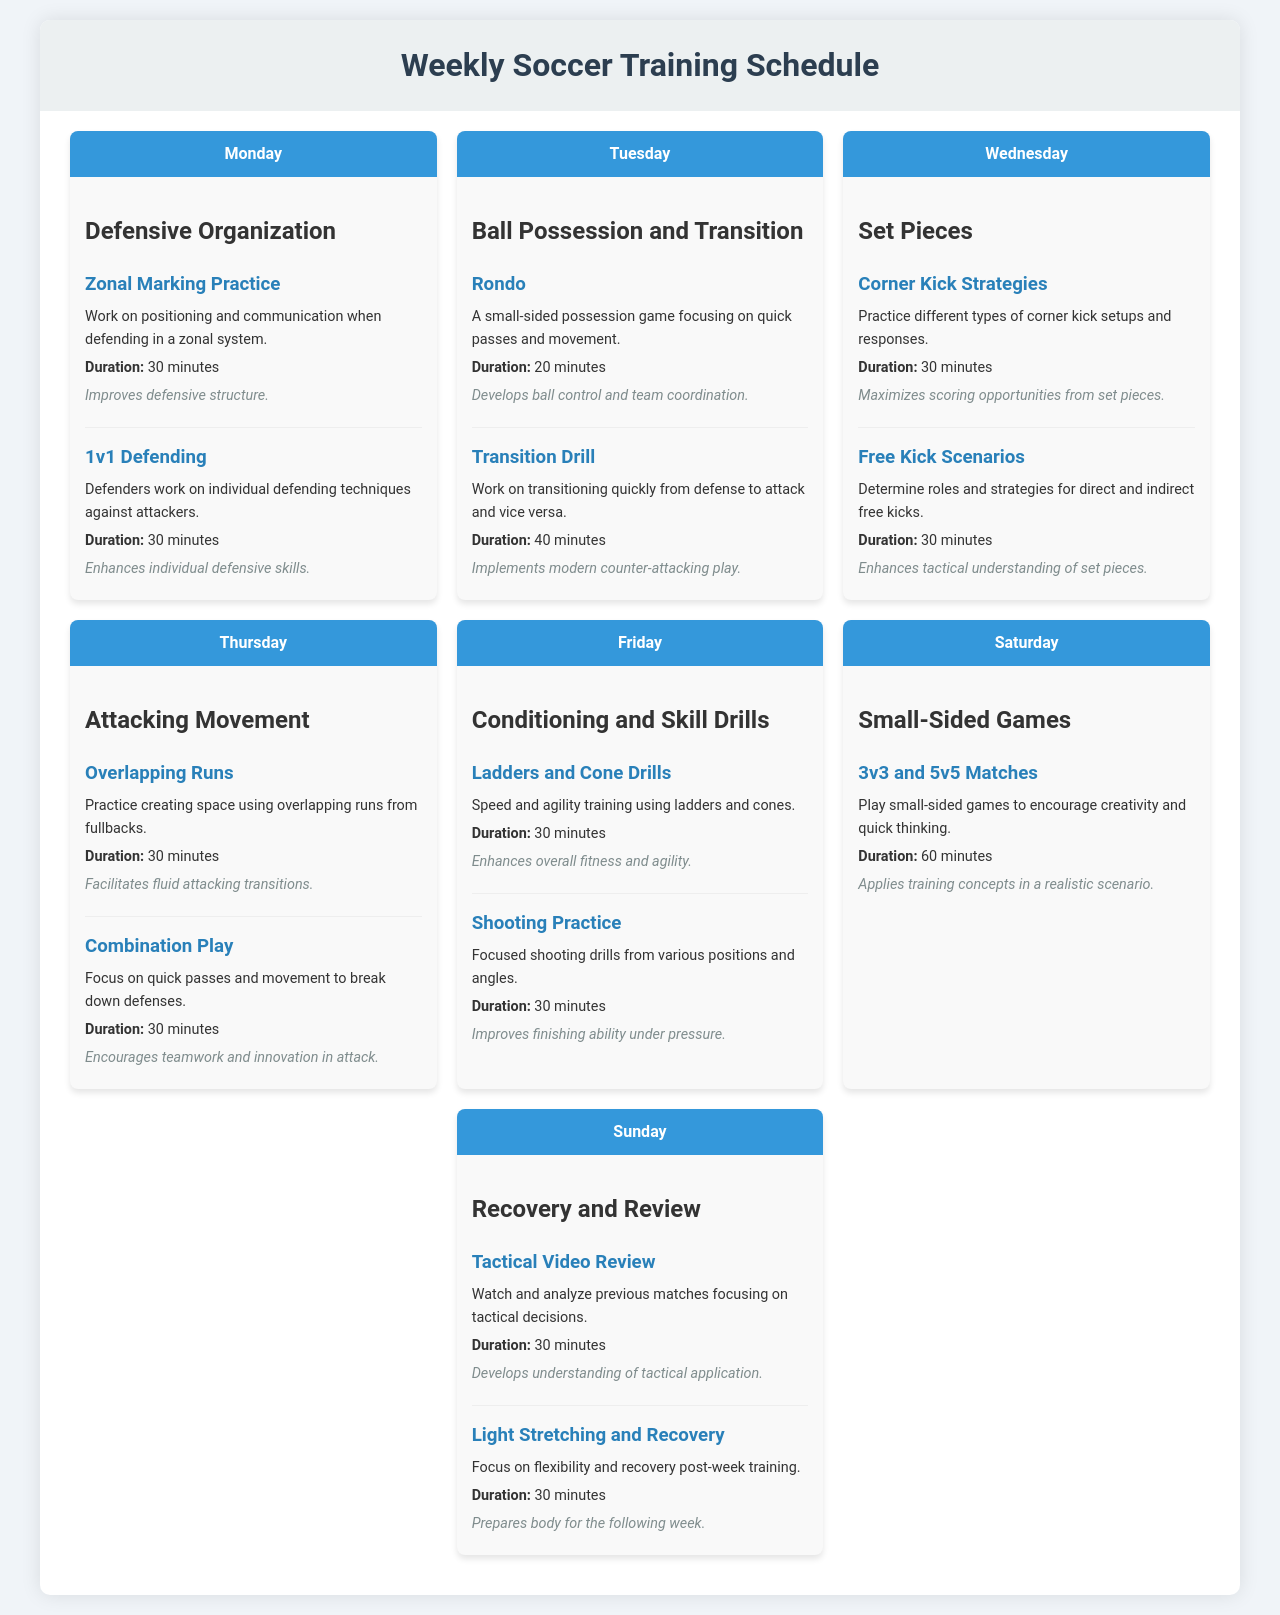What is the main focus of Monday's training? The main focus for Monday's training is "Defensive Organization."
Answer: Defensive Organization How long is the Transition Drill scheduled for? The Transition Drill is scheduled for 40 minutes as specified under Tuesday's training.
Answer: 40 minutes What type of games are played on Saturday? On Saturday, the training involves "Small-Sided Games."
Answer: Small-Sided Games What drill involves practicing quick passes and movement? The "Rondo" drill focuses on quick passes and movement during Tuesday's training.
Answer: Rondo Which day features a Tactical Video Review? The Tactical Video Review is scheduled for Sunday.
Answer: Sunday How many players are involved in the 3v3 and 5v5 matches? The matches involve either 3 players or 5 players on each team, as mentioned in Saturday's training.
Answer: 3v3 and 5v5 What is the emphasis of Thursday's training session? The emphasis of Thursday's training session is on "Attacking Movement."
Answer: Attacking Movement What technique is practiced in the 1v1 Defending drill? The 1v1 Defending drill practices individual defending techniques.
Answer: Individual defending techniques How long is the practice for Corner Kick Strategies? The practice for Corner Kick Strategies is scheduled for 30 minutes on Wednesday.
Answer: 30 minutes 